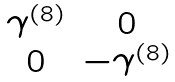Convert formula to latex. <formula><loc_0><loc_0><loc_500><loc_500>\begin{matrix} \gamma ^ { ( 8 ) } & 0 \\ 0 & - \gamma ^ { ( 8 ) } \end{matrix}</formula> 